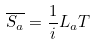<formula> <loc_0><loc_0><loc_500><loc_500>\overline { S _ { a } } = \frac { 1 } { i } L _ { a } T</formula> 